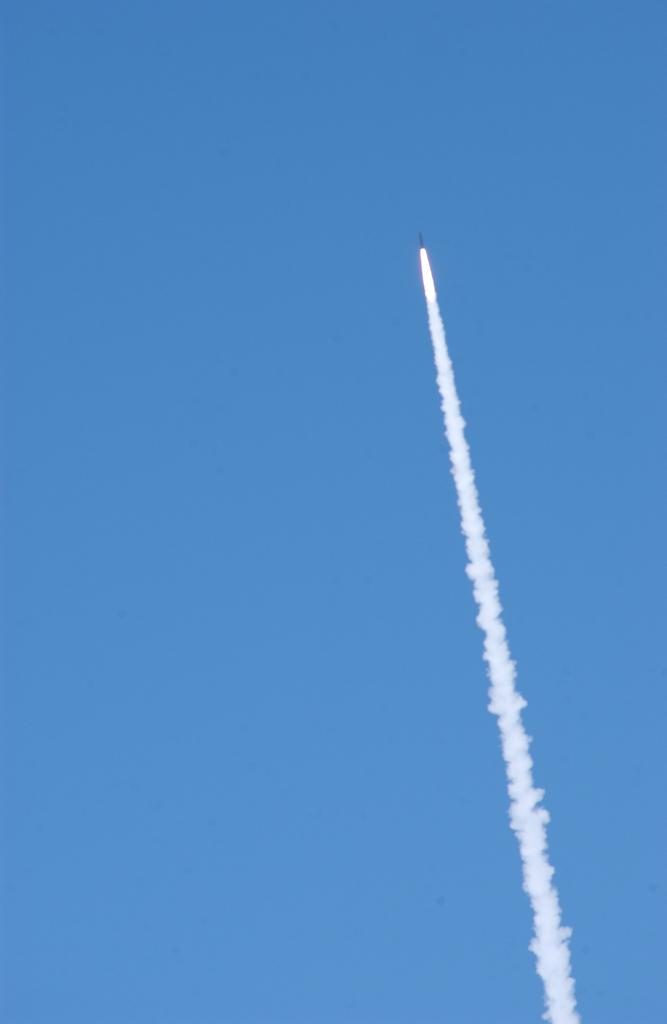What is the main subject of the image? The main subject of the image is a rocket flying. What is the weather condition in the image? There is fog in the image, which suggests a cloudy or misty condition. What can be seen in the background of the image? The sky is visible in the background of the image. What type of door can be seen on the rocket in the image? There is no door visible on the rocket in the image. How many fingers can be seen on the girl in the image? There is no girl present in the image. 